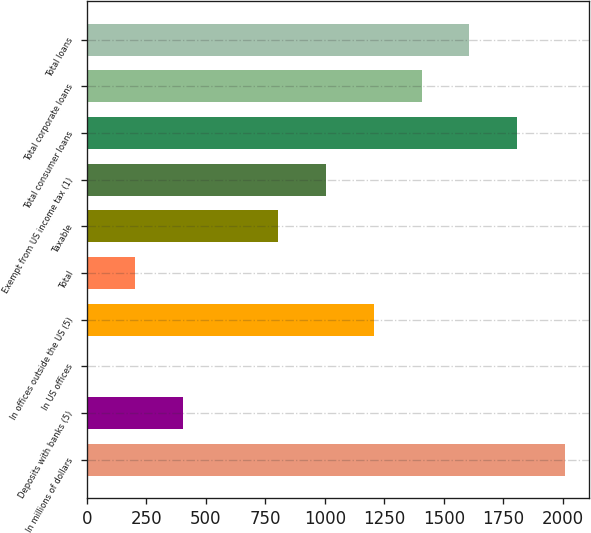<chart> <loc_0><loc_0><loc_500><loc_500><bar_chart><fcel>In millions of dollars<fcel>Deposits with banks (5)<fcel>In US offices<fcel>In offices outside the US (5)<fcel>Total<fcel>Taxable<fcel>Exempt from US income tax (1)<fcel>Total consumer loans<fcel>Total corporate loans<fcel>Total loans<nl><fcel>2008<fcel>404.06<fcel>3.08<fcel>1206.02<fcel>203.57<fcel>805.04<fcel>1005.53<fcel>1807.49<fcel>1406.51<fcel>1607<nl></chart> 